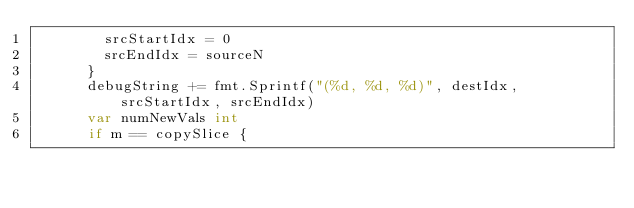Convert code to text. <code><loc_0><loc_0><loc_500><loc_500><_Go_>				srcStartIdx = 0
				srcEndIdx = sourceN
			}
			debugString += fmt.Sprintf("(%d, %d, %d)", destIdx, srcStartIdx, srcEndIdx)
			var numNewVals int
			if m == copySlice {</code> 